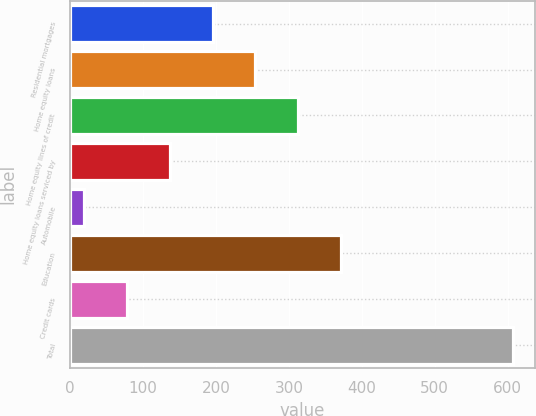Convert chart. <chart><loc_0><loc_0><loc_500><loc_500><bar_chart><fcel>Residential mortgages<fcel>Home equity loans<fcel>Home equity lines of credit<fcel>Home equity loans serviced by<fcel>Automobile<fcel>Education<fcel>Credit cards<fcel>Total<nl><fcel>195.4<fcel>254.2<fcel>313<fcel>136.6<fcel>19<fcel>371.8<fcel>77.8<fcel>607<nl></chart> 